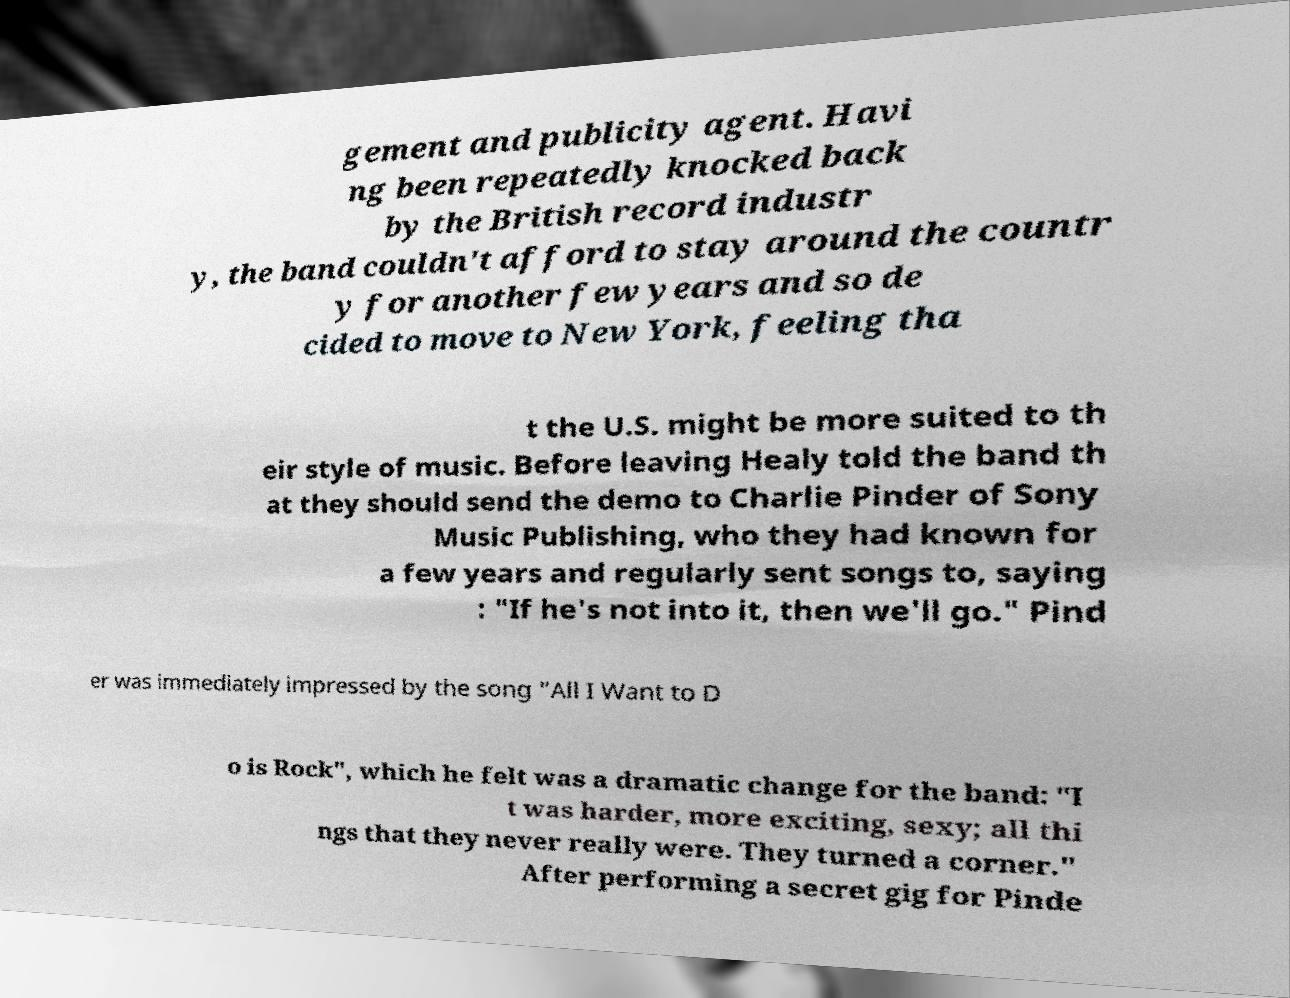I need the written content from this picture converted into text. Can you do that? gement and publicity agent. Havi ng been repeatedly knocked back by the British record industr y, the band couldn't afford to stay around the countr y for another few years and so de cided to move to New York, feeling tha t the U.S. might be more suited to th eir style of music. Before leaving Healy told the band th at they should send the demo to Charlie Pinder of Sony Music Publishing, who they had known for a few years and regularly sent songs to, saying : "If he's not into it, then we'll go." Pind er was immediately impressed by the song "All I Want to D o is Rock", which he felt was a dramatic change for the band: "I t was harder, more exciting, sexy; all thi ngs that they never really were. They turned a corner." After performing a secret gig for Pinde 